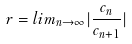<formula> <loc_0><loc_0><loc_500><loc_500>r = l i m _ { n \rightarrow \infty } | \frac { c _ { n } } { c _ { n + 1 } } |</formula> 